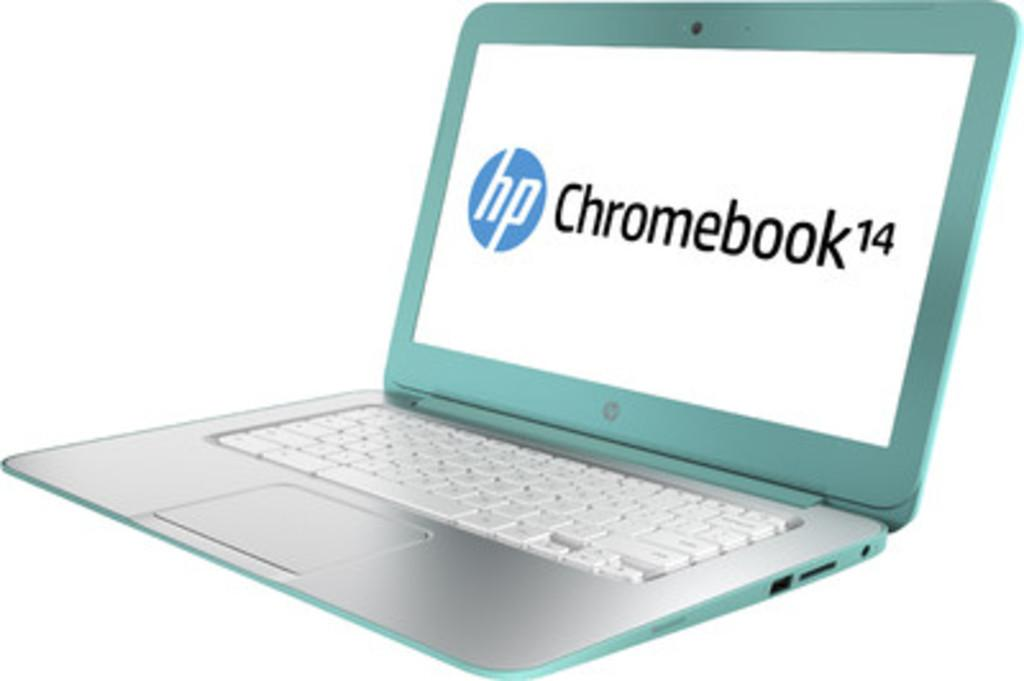<image>
Provide a brief description of the given image. a green hp chromebook 14 with a white keyboard 